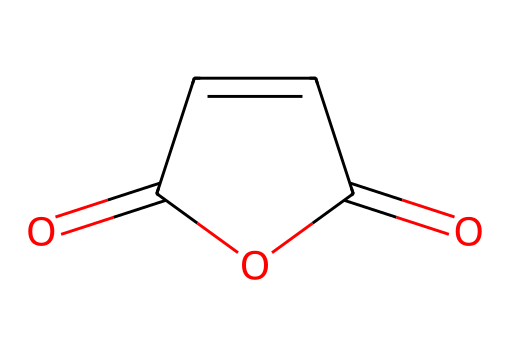What is the chemical name of the compound represented by the SMILES? The SMILES code O=C1OC(=O)C=C1 corresponds to maleic anhydride, which is a cyclic anhydride derived from maleic acid.
Answer: maleic anhydride How many carbon atoms are present in this molecule? By analyzing the SMILES, we see that there are four carbon atoms indicated by the 'C' in the structure.
Answer: 4 What type of functional group is present in maleic anhydride? The structure contains an anhydride functional group, which is represented by the cyclic structure and the carbonyl (C=O) functionalities.
Answer: anhydride How many double bonds are present in this molecule? In the SMILES, there are two double bonds indicated, one in the carbonyl group and another in the C=C double bond within the ring structure.
Answer: 2 What is the total number of oxygen atoms in this chemical? The SMILES shows two double-bonded oxygen atoms in the carbonyl groups of the anhydride plus one additional oxygen in the structure, giving a total of three.
Answer: 3 Does maleic anhydride contain any hydrogen atoms? Maleic anhydride, in its anhydride form, does not have any hydrogen atoms represented in the structure; therefore, it has none in this specific representation.
Answer: none 